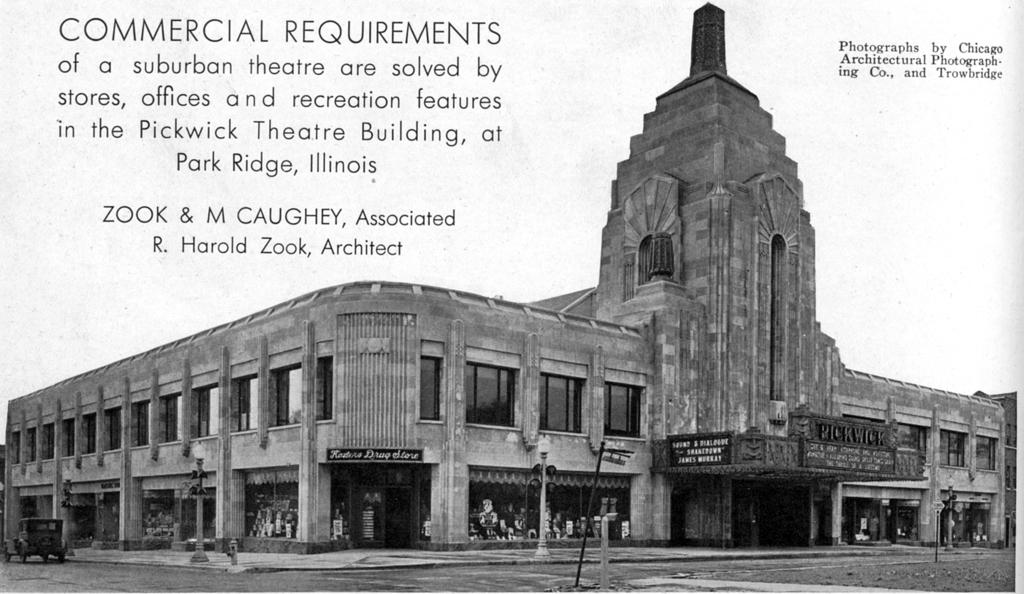What is the main subject of the image? There is a vehicle on the road in the image. What else can be seen in the image besides the vehicle? Electric poles with lights, a flag, at least one building, some objects, and text are visible in the image. Can you describe the electric poles in the image? The electric poles have lights on them. What is the purpose of the flag in the image? The purpose of the flag is not specified in the image, but it may represent a country, organization, or event. Is there a gun visible in the image? No, there is no gun present in the image. Can you light a match using the text in the image? No, the text in the image is not a match or a source of fire. 